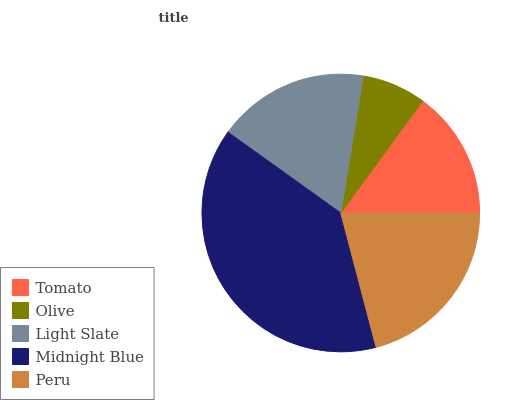Is Olive the minimum?
Answer yes or no. Yes. Is Midnight Blue the maximum?
Answer yes or no. Yes. Is Light Slate the minimum?
Answer yes or no. No. Is Light Slate the maximum?
Answer yes or no. No. Is Light Slate greater than Olive?
Answer yes or no. Yes. Is Olive less than Light Slate?
Answer yes or no. Yes. Is Olive greater than Light Slate?
Answer yes or no. No. Is Light Slate less than Olive?
Answer yes or no. No. Is Light Slate the high median?
Answer yes or no. Yes. Is Light Slate the low median?
Answer yes or no. Yes. Is Tomato the high median?
Answer yes or no. No. Is Peru the low median?
Answer yes or no. No. 